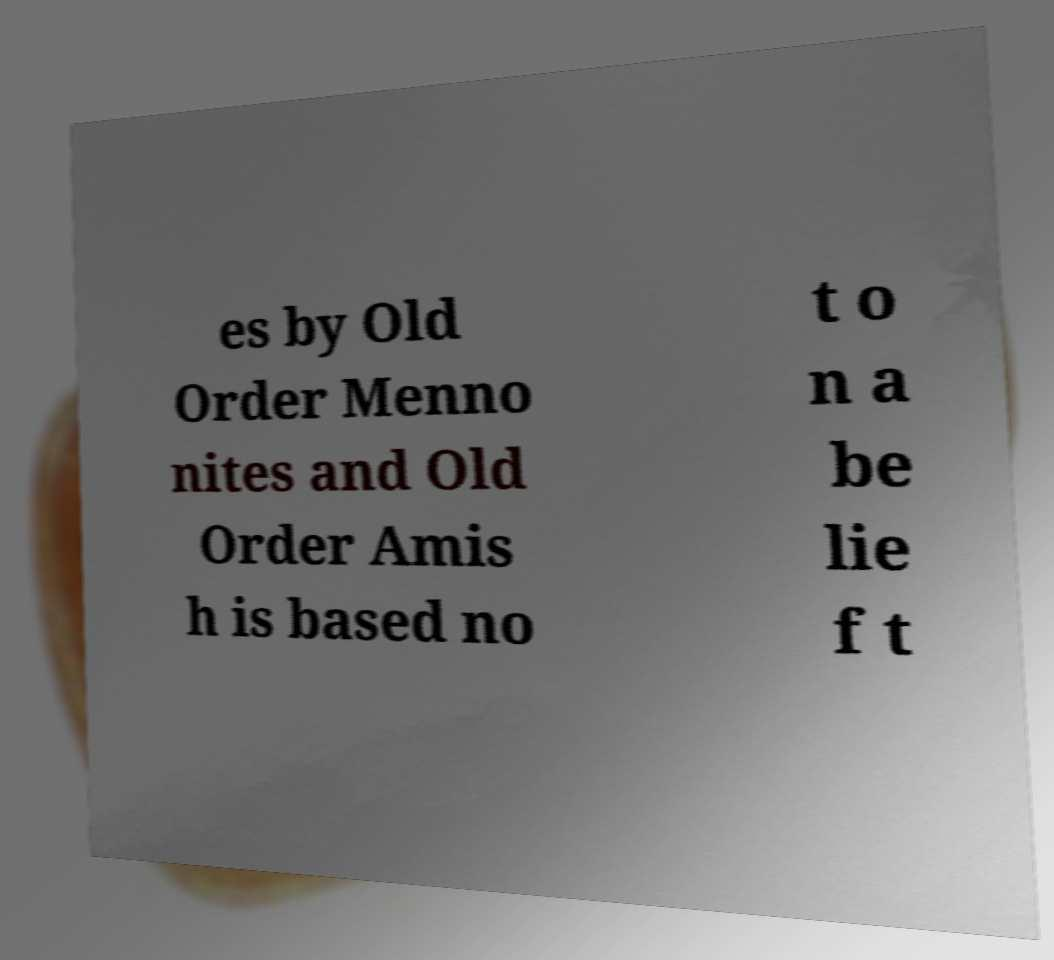I need the written content from this picture converted into text. Can you do that? es by Old Order Menno nites and Old Order Amis h is based no t o n a be lie f t 